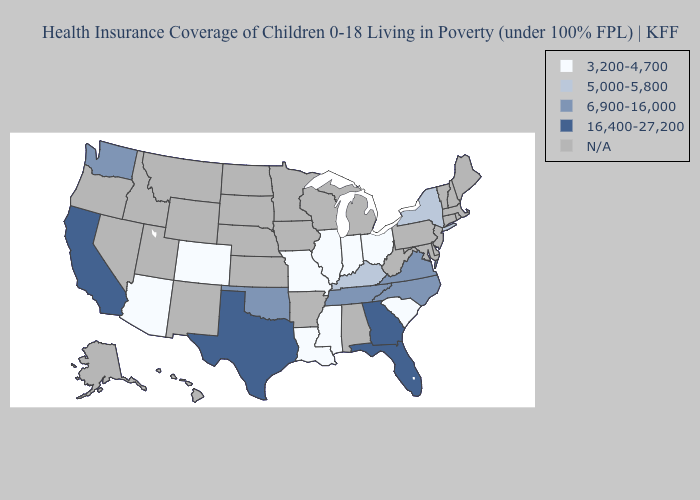Name the states that have a value in the range N/A?
Be succinct. Alabama, Alaska, Arkansas, Connecticut, Delaware, Hawaii, Idaho, Iowa, Kansas, Maine, Maryland, Massachusetts, Michigan, Minnesota, Montana, Nebraska, Nevada, New Hampshire, New Jersey, New Mexico, North Dakota, Oregon, Pennsylvania, Rhode Island, South Dakota, Utah, Vermont, West Virginia, Wisconsin, Wyoming. Does California have the highest value in the USA?
Quick response, please. Yes. Does Mississippi have the lowest value in the South?
Short answer required. Yes. What is the value of Hawaii?
Answer briefly. N/A. How many symbols are there in the legend?
Short answer required. 5. What is the lowest value in the USA?
Be succinct. 3,200-4,700. How many symbols are there in the legend?
Be succinct. 5. Name the states that have a value in the range 5,000-5,800?
Write a very short answer. Kentucky, New York. Name the states that have a value in the range 6,900-16,000?
Quick response, please. North Carolina, Oklahoma, Tennessee, Virginia, Washington. Among the states that border California , which have the highest value?
Be succinct. Arizona. Among the states that border Nevada , which have the highest value?
Short answer required. California. Name the states that have a value in the range 3,200-4,700?
Keep it brief. Arizona, Colorado, Illinois, Indiana, Louisiana, Mississippi, Missouri, Ohio, South Carolina. Name the states that have a value in the range N/A?
Keep it brief. Alabama, Alaska, Arkansas, Connecticut, Delaware, Hawaii, Idaho, Iowa, Kansas, Maine, Maryland, Massachusetts, Michigan, Minnesota, Montana, Nebraska, Nevada, New Hampshire, New Jersey, New Mexico, North Dakota, Oregon, Pennsylvania, Rhode Island, South Dakota, Utah, Vermont, West Virginia, Wisconsin, Wyoming. 